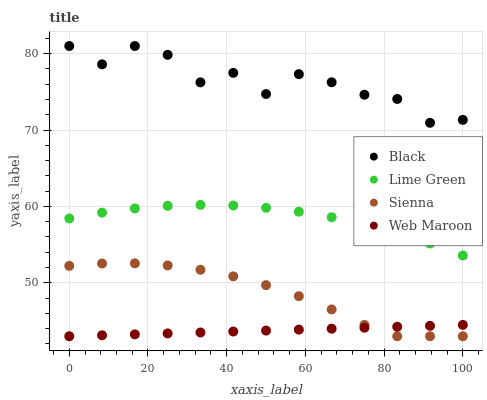Does Web Maroon have the minimum area under the curve?
Answer yes or no. Yes. Does Black have the maximum area under the curve?
Answer yes or no. Yes. Does Lime Green have the minimum area under the curve?
Answer yes or no. No. Does Lime Green have the maximum area under the curve?
Answer yes or no. No. Is Web Maroon the smoothest?
Answer yes or no. Yes. Is Black the roughest?
Answer yes or no. Yes. Is Lime Green the smoothest?
Answer yes or no. No. Is Lime Green the roughest?
Answer yes or no. No. Does Sienna have the lowest value?
Answer yes or no. Yes. Does Lime Green have the lowest value?
Answer yes or no. No. Does Black have the highest value?
Answer yes or no. Yes. Does Lime Green have the highest value?
Answer yes or no. No. Is Sienna less than Black?
Answer yes or no. Yes. Is Lime Green greater than Web Maroon?
Answer yes or no. Yes. Does Sienna intersect Web Maroon?
Answer yes or no. Yes. Is Sienna less than Web Maroon?
Answer yes or no. No. Is Sienna greater than Web Maroon?
Answer yes or no. No. Does Sienna intersect Black?
Answer yes or no. No. 